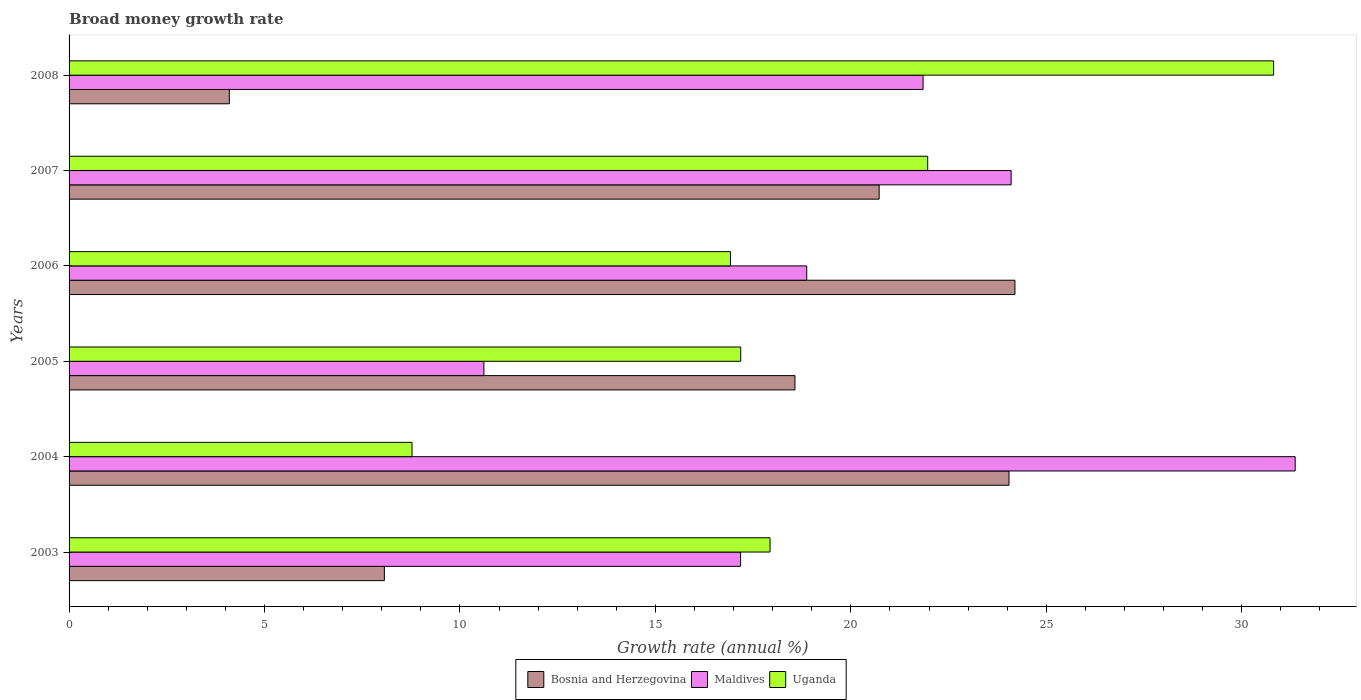How many different coloured bars are there?
Make the answer very short. 3. Are the number of bars per tick equal to the number of legend labels?
Offer a terse response. Yes. Are the number of bars on each tick of the Y-axis equal?
Give a very brief answer. Yes. How many bars are there on the 5th tick from the bottom?
Your answer should be compact. 3. What is the growth rate in Maldives in 2008?
Offer a very short reply. 21.85. Across all years, what is the maximum growth rate in Uganda?
Make the answer very short. 30.82. Across all years, what is the minimum growth rate in Uganda?
Your response must be concise. 8.77. In which year was the growth rate in Bosnia and Herzegovina maximum?
Your response must be concise. 2006. In which year was the growth rate in Uganda minimum?
Offer a terse response. 2004. What is the total growth rate in Bosnia and Herzegovina in the graph?
Offer a terse response. 99.71. What is the difference between the growth rate in Maldives in 2005 and that in 2006?
Provide a succinct answer. -8.26. What is the difference between the growth rate in Maldives in 2005 and the growth rate in Uganda in 2007?
Provide a short and direct response. -11.35. What is the average growth rate in Bosnia and Herzegovina per year?
Your response must be concise. 16.62. In the year 2006, what is the difference between the growth rate in Uganda and growth rate in Maldives?
Give a very brief answer. -1.95. What is the ratio of the growth rate in Bosnia and Herzegovina in 2005 to that in 2008?
Ensure brevity in your answer.  4.53. What is the difference between the highest and the second highest growth rate in Uganda?
Make the answer very short. 8.85. What is the difference between the highest and the lowest growth rate in Uganda?
Your answer should be compact. 22.04. What does the 3rd bar from the top in 2006 represents?
Keep it short and to the point. Bosnia and Herzegovina. What does the 2nd bar from the bottom in 2006 represents?
Provide a succinct answer. Maldives. How many bars are there?
Provide a succinct answer. 18. What is the difference between two consecutive major ticks on the X-axis?
Keep it short and to the point. 5. Does the graph contain any zero values?
Provide a succinct answer. No. Does the graph contain grids?
Your answer should be very brief. No. Where does the legend appear in the graph?
Provide a short and direct response. Bottom center. How are the legend labels stacked?
Make the answer very short. Horizontal. What is the title of the graph?
Provide a short and direct response. Broad money growth rate. What is the label or title of the X-axis?
Your response must be concise. Growth rate (annual %). What is the label or title of the Y-axis?
Make the answer very short. Years. What is the Growth rate (annual %) of Bosnia and Herzegovina in 2003?
Keep it short and to the point. 8.07. What is the Growth rate (annual %) in Maldives in 2003?
Keep it short and to the point. 17.18. What is the Growth rate (annual %) of Uganda in 2003?
Offer a very short reply. 17.93. What is the Growth rate (annual %) of Bosnia and Herzegovina in 2004?
Your answer should be very brief. 24.05. What is the Growth rate (annual %) of Maldives in 2004?
Your answer should be very brief. 31.37. What is the Growth rate (annual %) in Uganda in 2004?
Offer a very short reply. 8.77. What is the Growth rate (annual %) in Bosnia and Herzegovina in 2005?
Give a very brief answer. 18.57. What is the Growth rate (annual %) of Maldives in 2005?
Provide a short and direct response. 10.61. What is the Growth rate (annual %) in Uganda in 2005?
Keep it short and to the point. 17.18. What is the Growth rate (annual %) of Bosnia and Herzegovina in 2006?
Ensure brevity in your answer.  24.2. What is the Growth rate (annual %) in Maldives in 2006?
Provide a short and direct response. 18.87. What is the Growth rate (annual %) in Uganda in 2006?
Provide a succinct answer. 16.92. What is the Growth rate (annual %) of Bosnia and Herzegovina in 2007?
Keep it short and to the point. 20.72. What is the Growth rate (annual %) of Maldives in 2007?
Give a very brief answer. 24.1. What is the Growth rate (annual %) in Uganda in 2007?
Your answer should be very brief. 21.97. What is the Growth rate (annual %) in Bosnia and Herzegovina in 2008?
Make the answer very short. 4.1. What is the Growth rate (annual %) of Maldives in 2008?
Offer a very short reply. 21.85. What is the Growth rate (annual %) of Uganda in 2008?
Your answer should be compact. 30.82. Across all years, what is the maximum Growth rate (annual %) in Bosnia and Herzegovina?
Offer a terse response. 24.2. Across all years, what is the maximum Growth rate (annual %) of Maldives?
Make the answer very short. 31.37. Across all years, what is the maximum Growth rate (annual %) of Uganda?
Keep it short and to the point. 30.82. Across all years, what is the minimum Growth rate (annual %) of Bosnia and Herzegovina?
Provide a short and direct response. 4.1. Across all years, what is the minimum Growth rate (annual %) of Maldives?
Your answer should be compact. 10.61. Across all years, what is the minimum Growth rate (annual %) in Uganda?
Ensure brevity in your answer.  8.77. What is the total Growth rate (annual %) in Bosnia and Herzegovina in the graph?
Offer a very short reply. 99.71. What is the total Growth rate (annual %) of Maldives in the graph?
Provide a succinct answer. 123.98. What is the total Growth rate (annual %) in Uganda in the graph?
Your answer should be very brief. 113.59. What is the difference between the Growth rate (annual %) of Bosnia and Herzegovina in 2003 and that in 2004?
Keep it short and to the point. -15.98. What is the difference between the Growth rate (annual %) of Maldives in 2003 and that in 2004?
Offer a terse response. -14.19. What is the difference between the Growth rate (annual %) of Uganda in 2003 and that in 2004?
Keep it short and to the point. 9.16. What is the difference between the Growth rate (annual %) in Bosnia and Herzegovina in 2003 and that in 2005?
Offer a terse response. -10.5. What is the difference between the Growth rate (annual %) in Maldives in 2003 and that in 2005?
Provide a succinct answer. 6.57. What is the difference between the Growth rate (annual %) in Bosnia and Herzegovina in 2003 and that in 2006?
Ensure brevity in your answer.  -16.13. What is the difference between the Growth rate (annual %) in Maldives in 2003 and that in 2006?
Your answer should be very brief. -1.69. What is the difference between the Growth rate (annual %) in Uganda in 2003 and that in 2006?
Ensure brevity in your answer.  1.01. What is the difference between the Growth rate (annual %) of Bosnia and Herzegovina in 2003 and that in 2007?
Offer a very short reply. -12.66. What is the difference between the Growth rate (annual %) in Maldives in 2003 and that in 2007?
Ensure brevity in your answer.  -6.92. What is the difference between the Growth rate (annual %) in Uganda in 2003 and that in 2007?
Offer a very short reply. -4.03. What is the difference between the Growth rate (annual %) in Bosnia and Herzegovina in 2003 and that in 2008?
Ensure brevity in your answer.  3.97. What is the difference between the Growth rate (annual %) of Maldives in 2003 and that in 2008?
Provide a succinct answer. -4.67. What is the difference between the Growth rate (annual %) in Uganda in 2003 and that in 2008?
Give a very brief answer. -12.88. What is the difference between the Growth rate (annual %) in Bosnia and Herzegovina in 2004 and that in 2005?
Ensure brevity in your answer.  5.48. What is the difference between the Growth rate (annual %) of Maldives in 2004 and that in 2005?
Your answer should be compact. 20.76. What is the difference between the Growth rate (annual %) of Uganda in 2004 and that in 2005?
Offer a very short reply. -8.41. What is the difference between the Growth rate (annual %) of Bosnia and Herzegovina in 2004 and that in 2006?
Your answer should be very brief. -0.15. What is the difference between the Growth rate (annual %) in Maldives in 2004 and that in 2006?
Offer a very short reply. 12.5. What is the difference between the Growth rate (annual %) of Uganda in 2004 and that in 2006?
Ensure brevity in your answer.  -8.15. What is the difference between the Growth rate (annual %) of Bosnia and Herzegovina in 2004 and that in 2007?
Your response must be concise. 3.32. What is the difference between the Growth rate (annual %) in Maldives in 2004 and that in 2007?
Make the answer very short. 7.27. What is the difference between the Growth rate (annual %) in Uganda in 2004 and that in 2007?
Your answer should be compact. -13.19. What is the difference between the Growth rate (annual %) of Bosnia and Herzegovina in 2004 and that in 2008?
Your answer should be compact. 19.95. What is the difference between the Growth rate (annual %) of Maldives in 2004 and that in 2008?
Your answer should be compact. 9.52. What is the difference between the Growth rate (annual %) in Uganda in 2004 and that in 2008?
Your response must be concise. -22.04. What is the difference between the Growth rate (annual %) of Bosnia and Herzegovina in 2005 and that in 2006?
Keep it short and to the point. -5.63. What is the difference between the Growth rate (annual %) in Maldives in 2005 and that in 2006?
Your response must be concise. -8.26. What is the difference between the Growth rate (annual %) of Uganda in 2005 and that in 2006?
Keep it short and to the point. 0.26. What is the difference between the Growth rate (annual %) of Bosnia and Herzegovina in 2005 and that in 2007?
Your answer should be very brief. -2.15. What is the difference between the Growth rate (annual %) in Maldives in 2005 and that in 2007?
Provide a short and direct response. -13.49. What is the difference between the Growth rate (annual %) in Uganda in 2005 and that in 2007?
Provide a short and direct response. -4.78. What is the difference between the Growth rate (annual %) in Bosnia and Herzegovina in 2005 and that in 2008?
Ensure brevity in your answer.  14.47. What is the difference between the Growth rate (annual %) of Maldives in 2005 and that in 2008?
Your response must be concise. -11.24. What is the difference between the Growth rate (annual %) of Uganda in 2005 and that in 2008?
Keep it short and to the point. -13.63. What is the difference between the Growth rate (annual %) of Bosnia and Herzegovina in 2006 and that in 2007?
Provide a succinct answer. 3.47. What is the difference between the Growth rate (annual %) in Maldives in 2006 and that in 2007?
Give a very brief answer. -5.23. What is the difference between the Growth rate (annual %) in Uganda in 2006 and that in 2007?
Provide a short and direct response. -5.05. What is the difference between the Growth rate (annual %) of Bosnia and Herzegovina in 2006 and that in 2008?
Provide a succinct answer. 20.1. What is the difference between the Growth rate (annual %) in Maldives in 2006 and that in 2008?
Ensure brevity in your answer.  -2.98. What is the difference between the Growth rate (annual %) in Uganda in 2006 and that in 2008?
Ensure brevity in your answer.  -13.9. What is the difference between the Growth rate (annual %) in Bosnia and Herzegovina in 2007 and that in 2008?
Provide a short and direct response. 16.62. What is the difference between the Growth rate (annual %) in Maldives in 2007 and that in 2008?
Give a very brief answer. 2.25. What is the difference between the Growth rate (annual %) in Uganda in 2007 and that in 2008?
Provide a short and direct response. -8.85. What is the difference between the Growth rate (annual %) of Bosnia and Herzegovina in 2003 and the Growth rate (annual %) of Maldives in 2004?
Provide a succinct answer. -23.3. What is the difference between the Growth rate (annual %) of Bosnia and Herzegovina in 2003 and the Growth rate (annual %) of Uganda in 2004?
Your answer should be compact. -0.71. What is the difference between the Growth rate (annual %) of Maldives in 2003 and the Growth rate (annual %) of Uganda in 2004?
Provide a succinct answer. 8.41. What is the difference between the Growth rate (annual %) in Bosnia and Herzegovina in 2003 and the Growth rate (annual %) in Maldives in 2005?
Provide a succinct answer. -2.55. What is the difference between the Growth rate (annual %) in Bosnia and Herzegovina in 2003 and the Growth rate (annual %) in Uganda in 2005?
Make the answer very short. -9.12. What is the difference between the Growth rate (annual %) in Maldives in 2003 and the Growth rate (annual %) in Uganda in 2005?
Make the answer very short. -0. What is the difference between the Growth rate (annual %) in Bosnia and Herzegovina in 2003 and the Growth rate (annual %) in Maldives in 2006?
Ensure brevity in your answer.  -10.81. What is the difference between the Growth rate (annual %) of Bosnia and Herzegovina in 2003 and the Growth rate (annual %) of Uganda in 2006?
Give a very brief answer. -8.85. What is the difference between the Growth rate (annual %) in Maldives in 2003 and the Growth rate (annual %) in Uganda in 2006?
Make the answer very short. 0.26. What is the difference between the Growth rate (annual %) in Bosnia and Herzegovina in 2003 and the Growth rate (annual %) in Maldives in 2007?
Keep it short and to the point. -16.03. What is the difference between the Growth rate (annual %) of Bosnia and Herzegovina in 2003 and the Growth rate (annual %) of Uganda in 2007?
Give a very brief answer. -13.9. What is the difference between the Growth rate (annual %) in Maldives in 2003 and the Growth rate (annual %) in Uganda in 2007?
Your answer should be very brief. -4.79. What is the difference between the Growth rate (annual %) of Bosnia and Herzegovina in 2003 and the Growth rate (annual %) of Maldives in 2008?
Make the answer very short. -13.78. What is the difference between the Growth rate (annual %) of Bosnia and Herzegovina in 2003 and the Growth rate (annual %) of Uganda in 2008?
Offer a very short reply. -22.75. What is the difference between the Growth rate (annual %) in Maldives in 2003 and the Growth rate (annual %) in Uganda in 2008?
Make the answer very short. -13.64. What is the difference between the Growth rate (annual %) in Bosnia and Herzegovina in 2004 and the Growth rate (annual %) in Maldives in 2005?
Your response must be concise. 13.43. What is the difference between the Growth rate (annual %) in Bosnia and Herzegovina in 2004 and the Growth rate (annual %) in Uganda in 2005?
Your answer should be compact. 6.86. What is the difference between the Growth rate (annual %) of Maldives in 2004 and the Growth rate (annual %) of Uganda in 2005?
Your response must be concise. 14.19. What is the difference between the Growth rate (annual %) in Bosnia and Herzegovina in 2004 and the Growth rate (annual %) in Maldives in 2006?
Provide a succinct answer. 5.17. What is the difference between the Growth rate (annual %) in Bosnia and Herzegovina in 2004 and the Growth rate (annual %) in Uganda in 2006?
Your response must be concise. 7.13. What is the difference between the Growth rate (annual %) of Maldives in 2004 and the Growth rate (annual %) of Uganda in 2006?
Keep it short and to the point. 14.45. What is the difference between the Growth rate (annual %) in Bosnia and Herzegovina in 2004 and the Growth rate (annual %) in Maldives in 2007?
Ensure brevity in your answer.  -0.06. What is the difference between the Growth rate (annual %) of Bosnia and Herzegovina in 2004 and the Growth rate (annual %) of Uganda in 2007?
Ensure brevity in your answer.  2.08. What is the difference between the Growth rate (annual %) of Maldives in 2004 and the Growth rate (annual %) of Uganda in 2007?
Ensure brevity in your answer.  9.4. What is the difference between the Growth rate (annual %) in Bosnia and Herzegovina in 2004 and the Growth rate (annual %) in Maldives in 2008?
Make the answer very short. 2.2. What is the difference between the Growth rate (annual %) in Bosnia and Herzegovina in 2004 and the Growth rate (annual %) in Uganda in 2008?
Keep it short and to the point. -6.77. What is the difference between the Growth rate (annual %) in Maldives in 2004 and the Growth rate (annual %) in Uganda in 2008?
Give a very brief answer. 0.55. What is the difference between the Growth rate (annual %) in Bosnia and Herzegovina in 2005 and the Growth rate (annual %) in Maldives in 2006?
Your response must be concise. -0.3. What is the difference between the Growth rate (annual %) in Bosnia and Herzegovina in 2005 and the Growth rate (annual %) in Uganda in 2006?
Ensure brevity in your answer.  1.65. What is the difference between the Growth rate (annual %) of Maldives in 2005 and the Growth rate (annual %) of Uganda in 2006?
Keep it short and to the point. -6.31. What is the difference between the Growth rate (annual %) in Bosnia and Herzegovina in 2005 and the Growth rate (annual %) in Maldives in 2007?
Your answer should be very brief. -5.53. What is the difference between the Growth rate (annual %) of Bosnia and Herzegovina in 2005 and the Growth rate (annual %) of Uganda in 2007?
Offer a terse response. -3.4. What is the difference between the Growth rate (annual %) of Maldives in 2005 and the Growth rate (annual %) of Uganda in 2007?
Provide a succinct answer. -11.35. What is the difference between the Growth rate (annual %) of Bosnia and Herzegovina in 2005 and the Growth rate (annual %) of Maldives in 2008?
Your answer should be compact. -3.28. What is the difference between the Growth rate (annual %) of Bosnia and Herzegovina in 2005 and the Growth rate (annual %) of Uganda in 2008?
Your answer should be compact. -12.25. What is the difference between the Growth rate (annual %) of Maldives in 2005 and the Growth rate (annual %) of Uganda in 2008?
Provide a succinct answer. -20.2. What is the difference between the Growth rate (annual %) of Bosnia and Herzegovina in 2006 and the Growth rate (annual %) of Maldives in 2007?
Provide a succinct answer. 0.1. What is the difference between the Growth rate (annual %) in Bosnia and Herzegovina in 2006 and the Growth rate (annual %) in Uganda in 2007?
Your answer should be very brief. 2.23. What is the difference between the Growth rate (annual %) in Maldives in 2006 and the Growth rate (annual %) in Uganda in 2007?
Offer a terse response. -3.09. What is the difference between the Growth rate (annual %) in Bosnia and Herzegovina in 2006 and the Growth rate (annual %) in Maldives in 2008?
Give a very brief answer. 2.35. What is the difference between the Growth rate (annual %) in Bosnia and Herzegovina in 2006 and the Growth rate (annual %) in Uganda in 2008?
Provide a short and direct response. -6.62. What is the difference between the Growth rate (annual %) of Maldives in 2006 and the Growth rate (annual %) of Uganda in 2008?
Provide a short and direct response. -11.94. What is the difference between the Growth rate (annual %) in Bosnia and Herzegovina in 2007 and the Growth rate (annual %) in Maldives in 2008?
Give a very brief answer. -1.12. What is the difference between the Growth rate (annual %) of Bosnia and Herzegovina in 2007 and the Growth rate (annual %) of Uganda in 2008?
Make the answer very short. -10.09. What is the difference between the Growth rate (annual %) of Maldives in 2007 and the Growth rate (annual %) of Uganda in 2008?
Your answer should be very brief. -6.72. What is the average Growth rate (annual %) of Bosnia and Herzegovina per year?
Your response must be concise. 16.62. What is the average Growth rate (annual %) of Maldives per year?
Make the answer very short. 20.66. What is the average Growth rate (annual %) in Uganda per year?
Your answer should be compact. 18.93. In the year 2003, what is the difference between the Growth rate (annual %) in Bosnia and Herzegovina and Growth rate (annual %) in Maldives?
Your answer should be compact. -9.11. In the year 2003, what is the difference between the Growth rate (annual %) in Bosnia and Herzegovina and Growth rate (annual %) in Uganda?
Your answer should be compact. -9.87. In the year 2003, what is the difference between the Growth rate (annual %) in Maldives and Growth rate (annual %) in Uganda?
Ensure brevity in your answer.  -0.75. In the year 2004, what is the difference between the Growth rate (annual %) of Bosnia and Herzegovina and Growth rate (annual %) of Maldives?
Your answer should be compact. -7.32. In the year 2004, what is the difference between the Growth rate (annual %) of Bosnia and Herzegovina and Growth rate (annual %) of Uganda?
Provide a short and direct response. 15.27. In the year 2004, what is the difference between the Growth rate (annual %) in Maldives and Growth rate (annual %) in Uganda?
Provide a succinct answer. 22.59. In the year 2005, what is the difference between the Growth rate (annual %) in Bosnia and Herzegovina and Growth rate (annual %) in Maldives?
Provide a succinct answer. 7.96. In the year 2005, what is the difference between the Growth rate (annual %) in Bosnia and Herzegovina and Growth rate (annual %) in Uganda?
Make the answer very short. 1.39. In the year 2005, what is the difference between the Growth rate (annual %) in Maldives and Growth rate (annual %) in Uganda?
Provide a short and direct response. -6.57. In the year 2006, what is the difference between the Growth rate (annual %) in Bosnia and Herzegovina and Growth rate (annual %) in Maldives?
Keep it short and to the point. 5.33. In the year 2006, what is the difference between the Growth rate (annual %) in Bosnia and Herzegovina and Growth rate (annual %) in Uganda?
Offer a very short reply. 7.28. In the year 2006, what is the difference between the Growth rate (annual %) of Maldives and Growth rate (annual %) of Uganda?
Make the answer very short. 1.95. In the year 2007, what is the difference between the Growth rate (annual %) in Bosnia and Herzegovina and Growth rate (annual %) in Maldives?
Make the answer very short. -3.38. In the year 2007, what is the difference between the Growth rate (annual %) of Bosnia and Herzegovina and Growth rate (annual %) of Uganda?
Provide a succinct answer. -1.24. In the year 2007, what is the difference between the Growth rate (annual %) in Maldives and Growth rate (annual %) in Uganda?
Your answer should be compact. 2.13. In the year 2008, what is the difference between the Growth rate (annual %) of Bosnia and Herzegovina and Growth rate (annual %) of Maldives?
Offer a terse response. -17.75. In the year 2008, what is the difference between the Growth rate (annual %) of Bosnia and Herzegovina and Growth rate (annual %) of Uganda?
Your response must be concise. -26.72. In the year 2008, what is the difference between the Growth rate (annual %) in Maldives and Growth rate (annual %) in Uganda?
Your response must be concise. -8.97. What is the ratio of the Growth rate (annual %) of Bosnia and Herzegovina in 2003 to that in 2004?
Make the answer very short. 0.34. What is the ratio of the Growth rate (annual %) in Maldives in 2003 to that in 2004?
Your response must be concise. 0.55. What is the ratio of the Growth rate (annual %) of Uganda in 2003 to that in 2004?
Offer a terse response. 2.04. What is the ratio of the Growth rate (annual %) of Bosnia and Herzegovina in 2003 to that in 2005?
Make the answer very short. 0.43. What is the ratio of the Growth rate (annual %) in Maldives in 2003 to that in 2005?
Your answer should be compact. 1.62. What is the ratio of the Growth rate (annual %) in Uganda in 2003 to that in 2005?
Your answer should be very brief. 1.04. What is the ratio of the Growth rate (annual %) in Bosnia and Herzegovina in 2003 to that in 2006?
Offer a terse response. 0.33. What is the ratio of the Growth rate (annual %) in Maldives in 2003 to that in 2006?
Offer a terse response. 0.91. What is the ratio of the Growth rate (annual %) of Uganda in 2003 to that in 2006?
Offer a terse response. 1.06. What is the ratio of the Growth rate (annual %) in Bosnia and Herzegovina in 2003 to that in 2007?
Provide a succinct answer. 0.39. What is the ratio of the Growth rate (annual %) in Maldives in 2003 to that in 2007?
Provide a succinct answer. 0.71. What is the ratio of the Growth rate (annual %) of Uganda in 2003 to that in 2007?
Provide a succinct answer. 0.82. What is the ratio of the Growth rate (annual %) in Bosnia and Herzegovina in 2003 to that in 2008?
Keep it short and to the point. 1.97. What is the ratio of the Growth rate (annual %) of Maldives in 2003 to that in 2008?
Your response must be concise. 0.79. What is the ratio of the Growth rate (annual %) of Uganda in 2003 to that in 2008?
Your answer should be very brief. 0.58. What is the ratio of the Growth rate (annual %) of Bosnia and Herzegovina in 2004 to that in 2005?
Keep it short and to the point. 1.29. What is the ratio of the Growth rate (annual %) in Maldives in 2004 to that in 2005?
Provide a short and direct response. 2.96. What is the ratio of the Growth rate (annual %) in Uganda in 2004 to that in 2005?
Offer a terse response. 0.51. What is the ratio of the Growth rate (annual %) of Maldives in 2004 to that in 2006?
Offer a very short reply. 1.66. What is the ratio of the Growth rate (annual %) of Uganda in 2004 to that in 2006?
Make the answer very short. 0.52. What is the ratio of the Growth rate (annual %) in Bosnia and Herzegovina in 2004 to that in 2007?
Offer a terse response. 1.16. What is the ratio of the Growth rate (annual %) of Maldives in 2004 to that in 2007?
Give a very brief answer. 1.3. What is the ratio of the Growth rate (annual %) in Uganda in 2004 to that in 2007?
Your answer should be very brief. 0.4. What is the ratio of the Growth rate (annual %) of Bosnia and Herzegovina in 2004 to that in 2008?
Keep it short and to the point. 5.86. What is the ratio of the Growth rate (annual %) of Maldives in 2004 to that in 2008?
Offer a terse response. 1.44. What is the ratio of the Growth rate (annual %) of Uganda in 2004 to that in 2008?
Provide a short and direct response. 0.28. What is the ratio of the Growth rate (annual %) of Bosnia and Herzegovina in 2005 to that in 2006?
Keep it short and to the point. 0.77. What is the ratio of the Growth rate (annual %) of Maldives in 2005 to that in 2006?
Provide a short and direct response. 0.56. What is the ratio of the Growth rate (annual %) in Uganda in 2005 to that in 2006?
Offer a very short reply. 1.02. What is the ratio of the Growth rate (annual %) of Bosnia and Herzegovina in 2005 to that in 2007?
Offer a very short reply. 0.9. What is the ratio of the Growth rate (annual %) of Maldives in 2005 to that in 2007?
Offer a terse response. 0.44. What is the ratio of the Growth rate (annual %) of Uganda in 2005 to that in 2007?
Provide a succinct answer. 0.78. What is the ratio of the Growth rate (annual %) in Bosnia and Herzegovina in 2005 to that in 2008?
Provide a short and direct response. 4.53. What is the ratio of the Growth rate (annual %) of Maldives in 2005 to that in 2008?
Offer a very short reply. 0.49. What is the ratio of the Growth rate (annual %) of Uganda in 2005 to that in 2008?
Ensure brevity in your answer.  0.56. What is the ratio of the Growth rate (annual %) of Bosnia and Herzegovina in 2006 to that in 2007?
Give a very brief answer. 1.17. What is the ratio of the Growth rate (annual %) in Maldives in 2006 to that in 2007?
Make the answer very short. 0.78. What is the ratio of the Growth rate (annual %) of Uganda in 2006 to that in 2007?
Your answer should be compact. 0.77. What is the ratio of the Growth rate (annual %) of Bosnia and Herzegovina in 2006 to that in 2008?
Your answer should be compact. 5.9. What is the ratio of the Growth rate (annual %) in Maldives in 2006 to that in 2008?
Provide a succinct answer. 0.86. What is the ratio of the Growth rate (annual %) of Uganda in 2006 to that in 2008?
Provide a succinct answer. 0.55. What is the ratio of the Growth rate (annual %) in Bosnia and Herzegovina in 2007 to that in 2008?
Offer a terse response. 5.05. What is the ratio of the Growth rate (annual %) in Maldives in 2007 to that in 2008?
Your response must be concise. 1.1. What is the ratio of the Growth rate (annual %) in Uganda in 2007 to that in 2008?
Offer a terse response. 0.71. What is the difference between the highest and the second highest Growth rate (annual %) in Bosnia and Herzegovina?
Offer a very short reply. 0.15. What is the difference between the highest and the second highest Growth rate (annual %) of Maldives?
Offer a terse response. 7.27. What is the difference between the highest and the second highest Growth rate (annual %) of Uganda?
Provide a succinct answer. 8.85. What is the difference between the highest and the lowest Growth rate (annual %) in Bosnia and Herzegovina?
Ensure brevity in your answer.  20.1. What is the difference between the highest and the lowest Growth rate (annual %) in Maldives?
Your answer should be very brief. 20.76. What is the difference between the highest and the lowest Growth rate (annual %) of Uganda?
Provide a succinct answer. 22.04. 